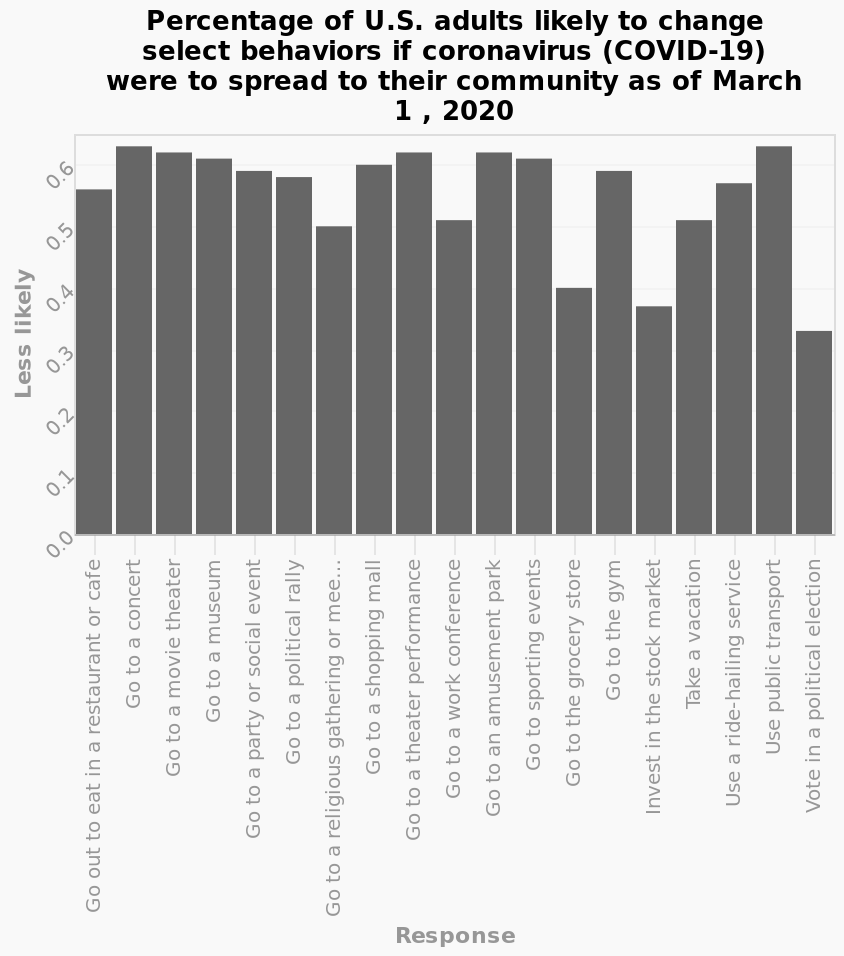<image>
What does the x-axis measure in the bar chart?  The x-axis measures the response in the bar chart. Offer a thorough analysis of the image. There aren't any clear patterns to be observed from this visualization. 